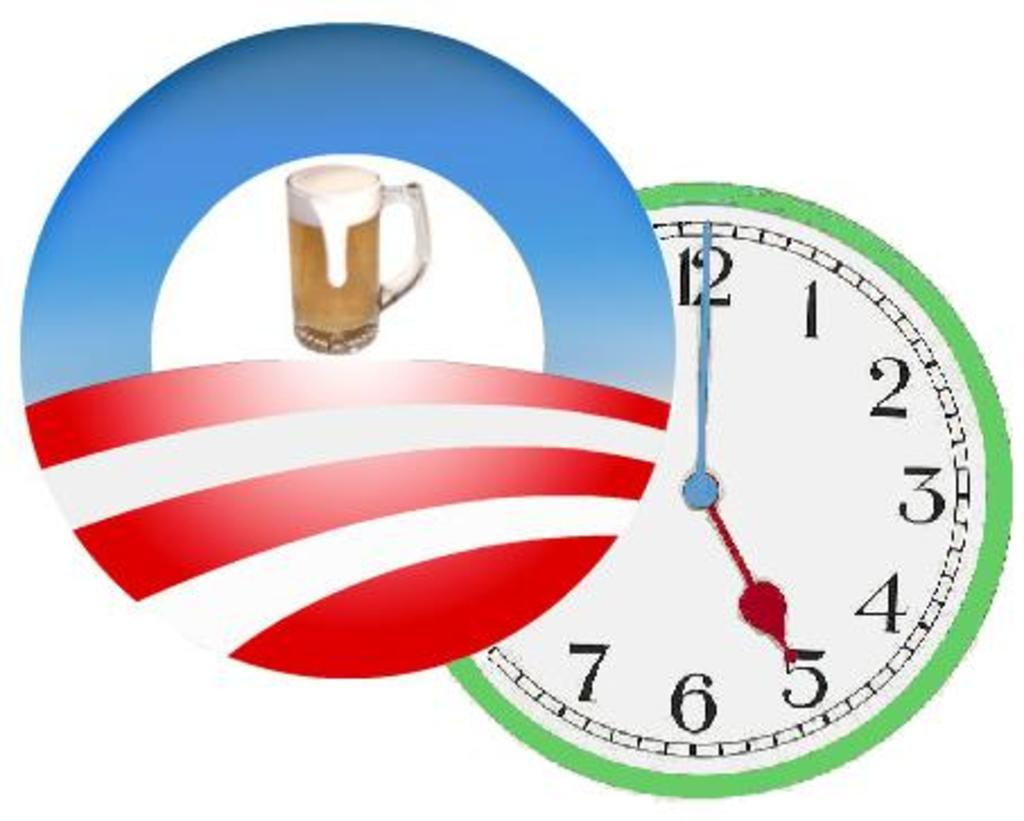<image>
Summarize the visual content of the image. a clock with the numbers 1 to 12 on it 